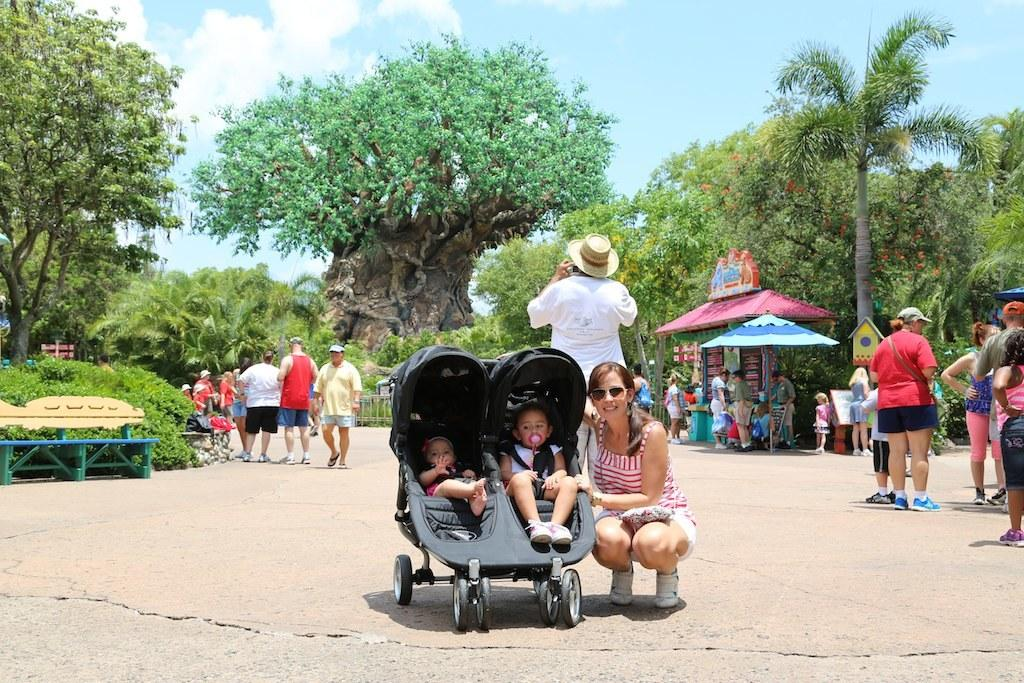Who is present in the image besides the kids? There is a woman and a person wearing a hat in the image. What are the kids doing in the image? The kids are in a vehicle. What can be seen in the background of the image? There are green trees in the image. What is the person standing behind the kids wearing? The person is wearing a hat. Where is the playground located in the image? There is no playground present in the image. What type of yoke is being used by the woman in the image? There is no yoke present in the image. 